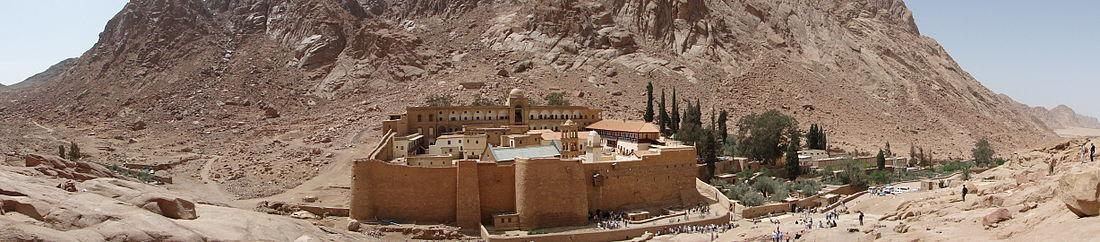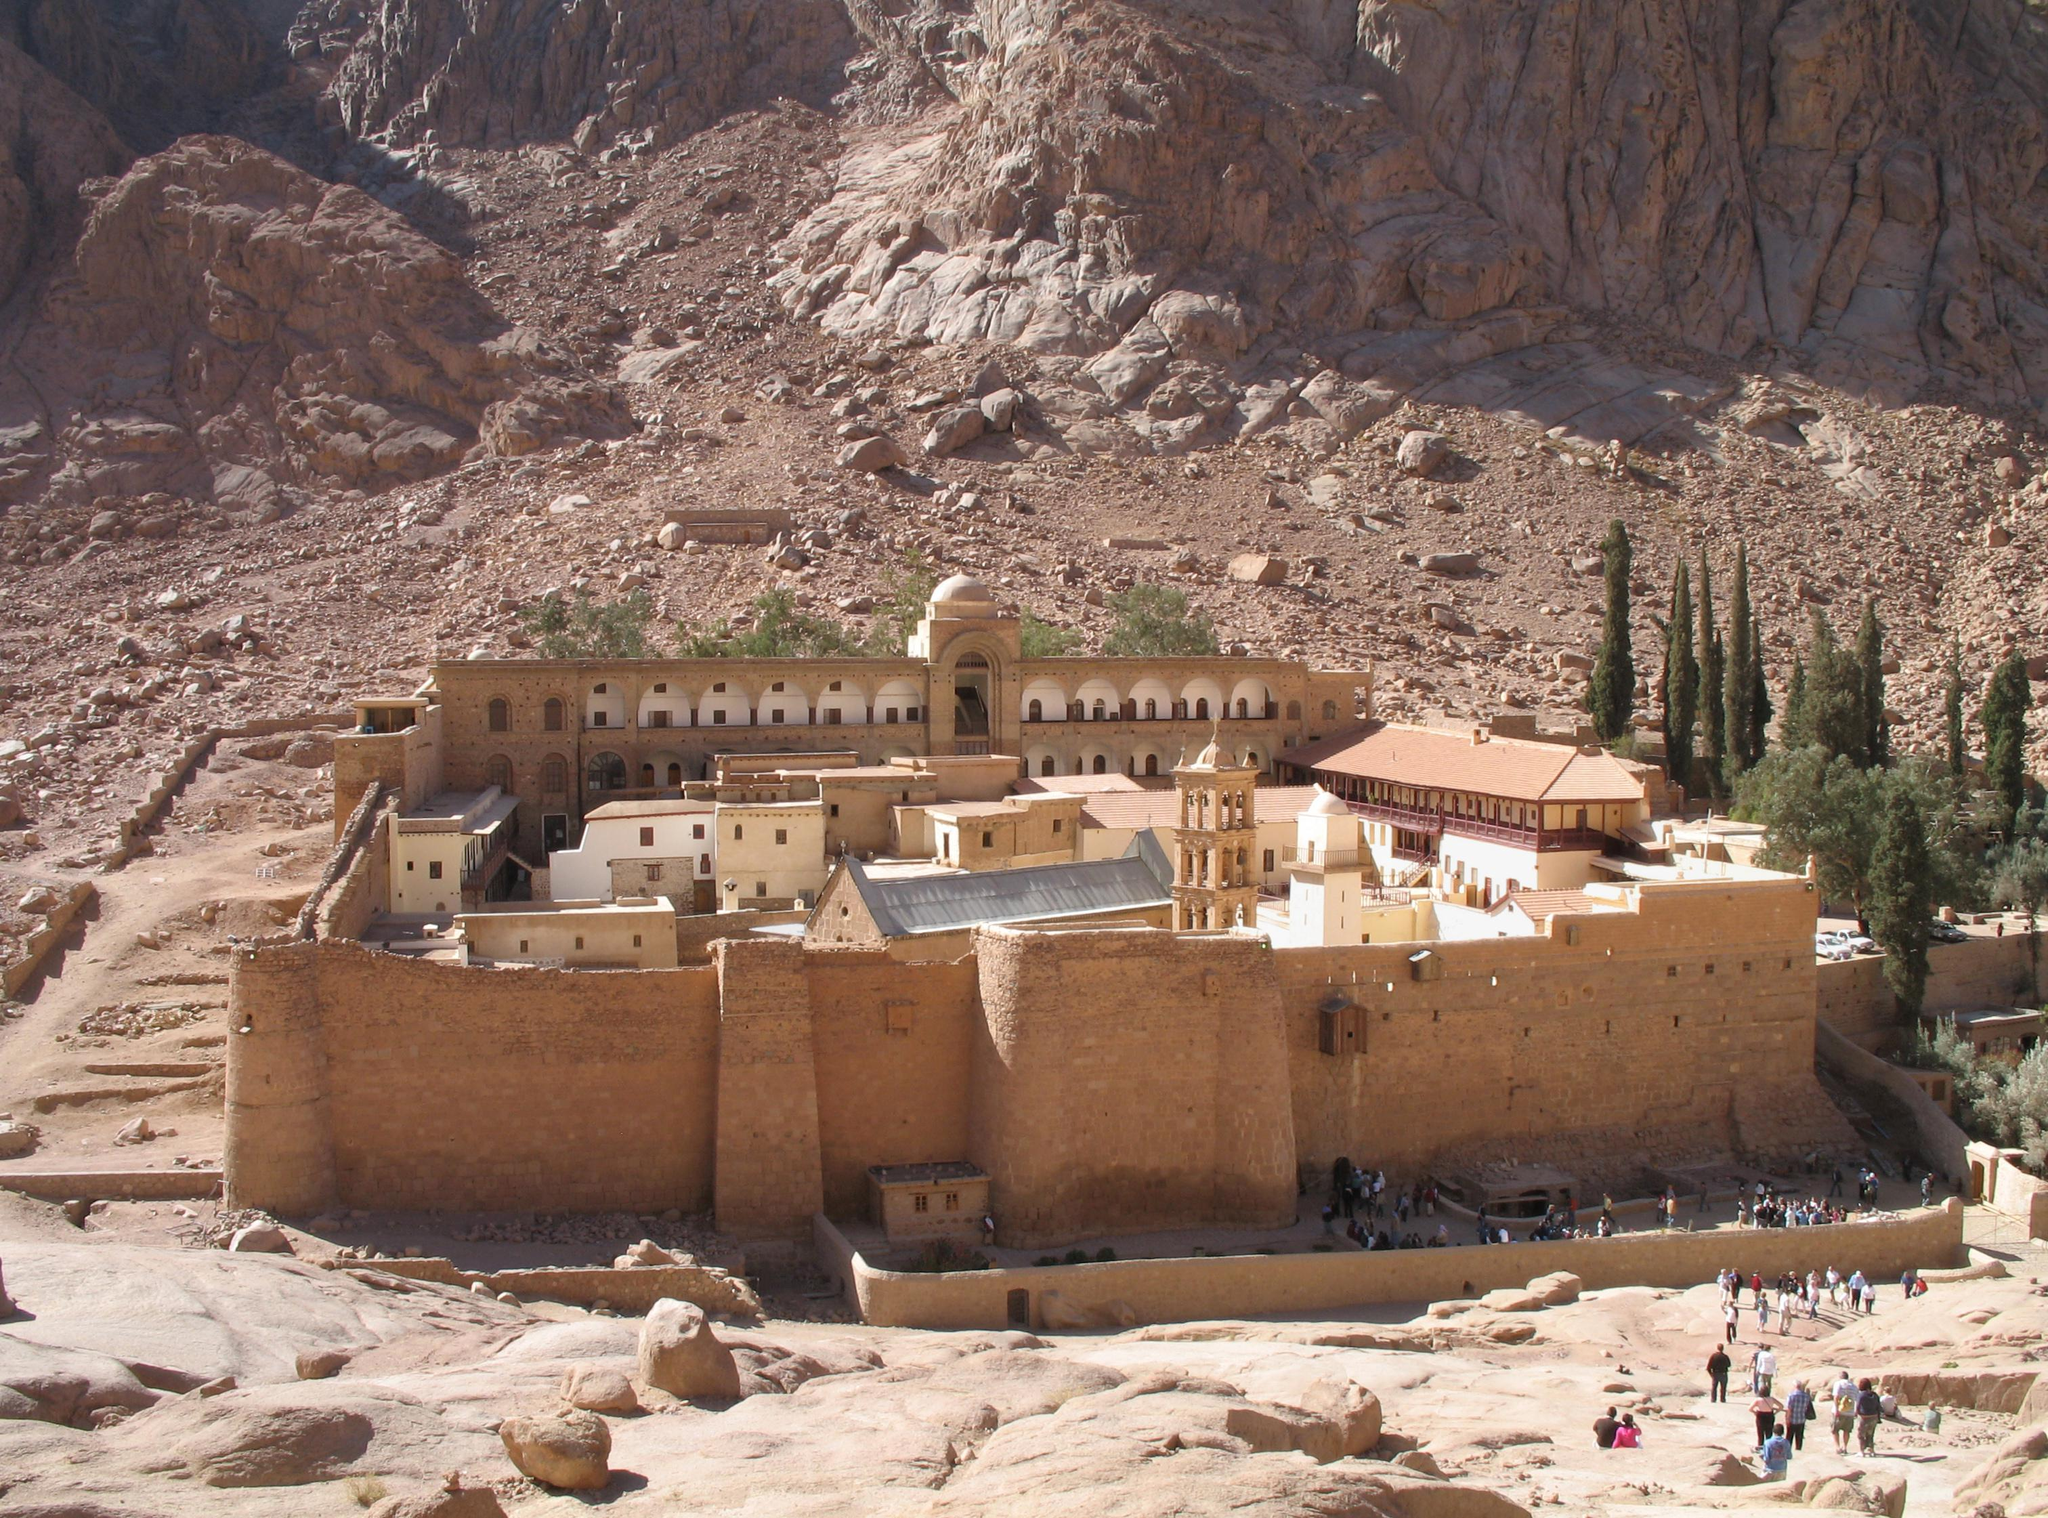The first image is the image on the left, the second image is the image on the right. Evaluate the accuracy of this statement regarding the images: "There is mountain in the bottom right of one image, next to and above the town, but not in the other image.". Is it true? Answer yes or no. No. The first image is the image on the left, the second image is the image on the right. Analyze the images presented: Is the assertion "The left and right image contains a total of two compounds facing forward." valid? Answer yes or no. Yes. 